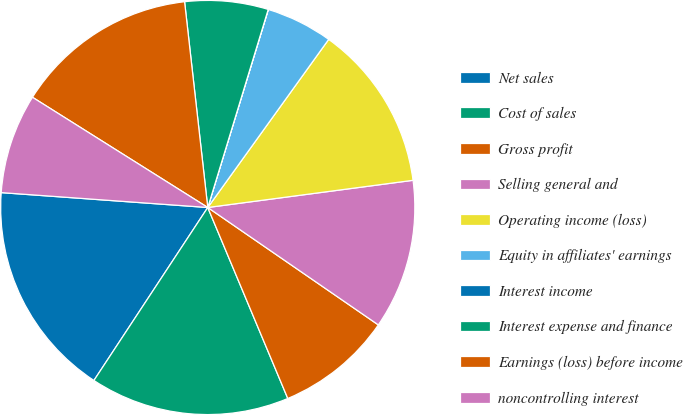Convert chart to OTSL. <chart><loc_0><loc_0><loc_500><loc_500><pie_chart><fcel>Net sales<fcel>Cost of sales<fcel>Gross profit<fcel>Selling general and<fcel>Operating income (loss)<fcel>Equity in affiliates' earnings<fcel>Interest income<fcel>Interest expense and finance<fcel>Earnings (loss) before income<fcel>noncontrolling interest<nl><fcel>16.88%<fcel>15.58%<fcel>9.09%<fcel>11.69%<fcel>12.98%<fcel>5.2%<fcel>0.01%<fcel>6.5%<fcel>14.28%<fcel>7.79%<nl></chart> 